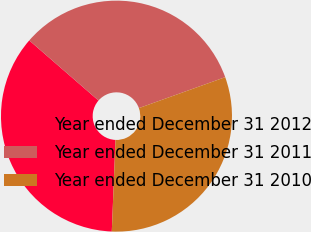<chart> <loc_0><loc_0><loc_500><loc_500><pie_chart><fcel>Year ended December 31 2012<fcel>Year ended December 31 2011<fcel>Year ended December 31 2010<nl><fcel>35.73%<fcel>33.14%<fcel>31.12%<nl></chart> 